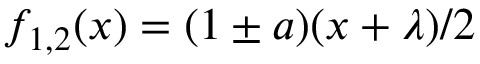<formula> <loc_0><loc_0><loc_500><loc_500>f _ { 1 , 2 } ( x ) = ( 1 \pm a ) ( x + \lambda ) / 2</formula> 